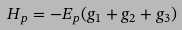<formula> <loc_0><loc_0><loc_500><loc_500>H _ { p } = - E _ { p } ( g _ { 1 } + g _ { 2 } + g _ { 3 } )</formula> 